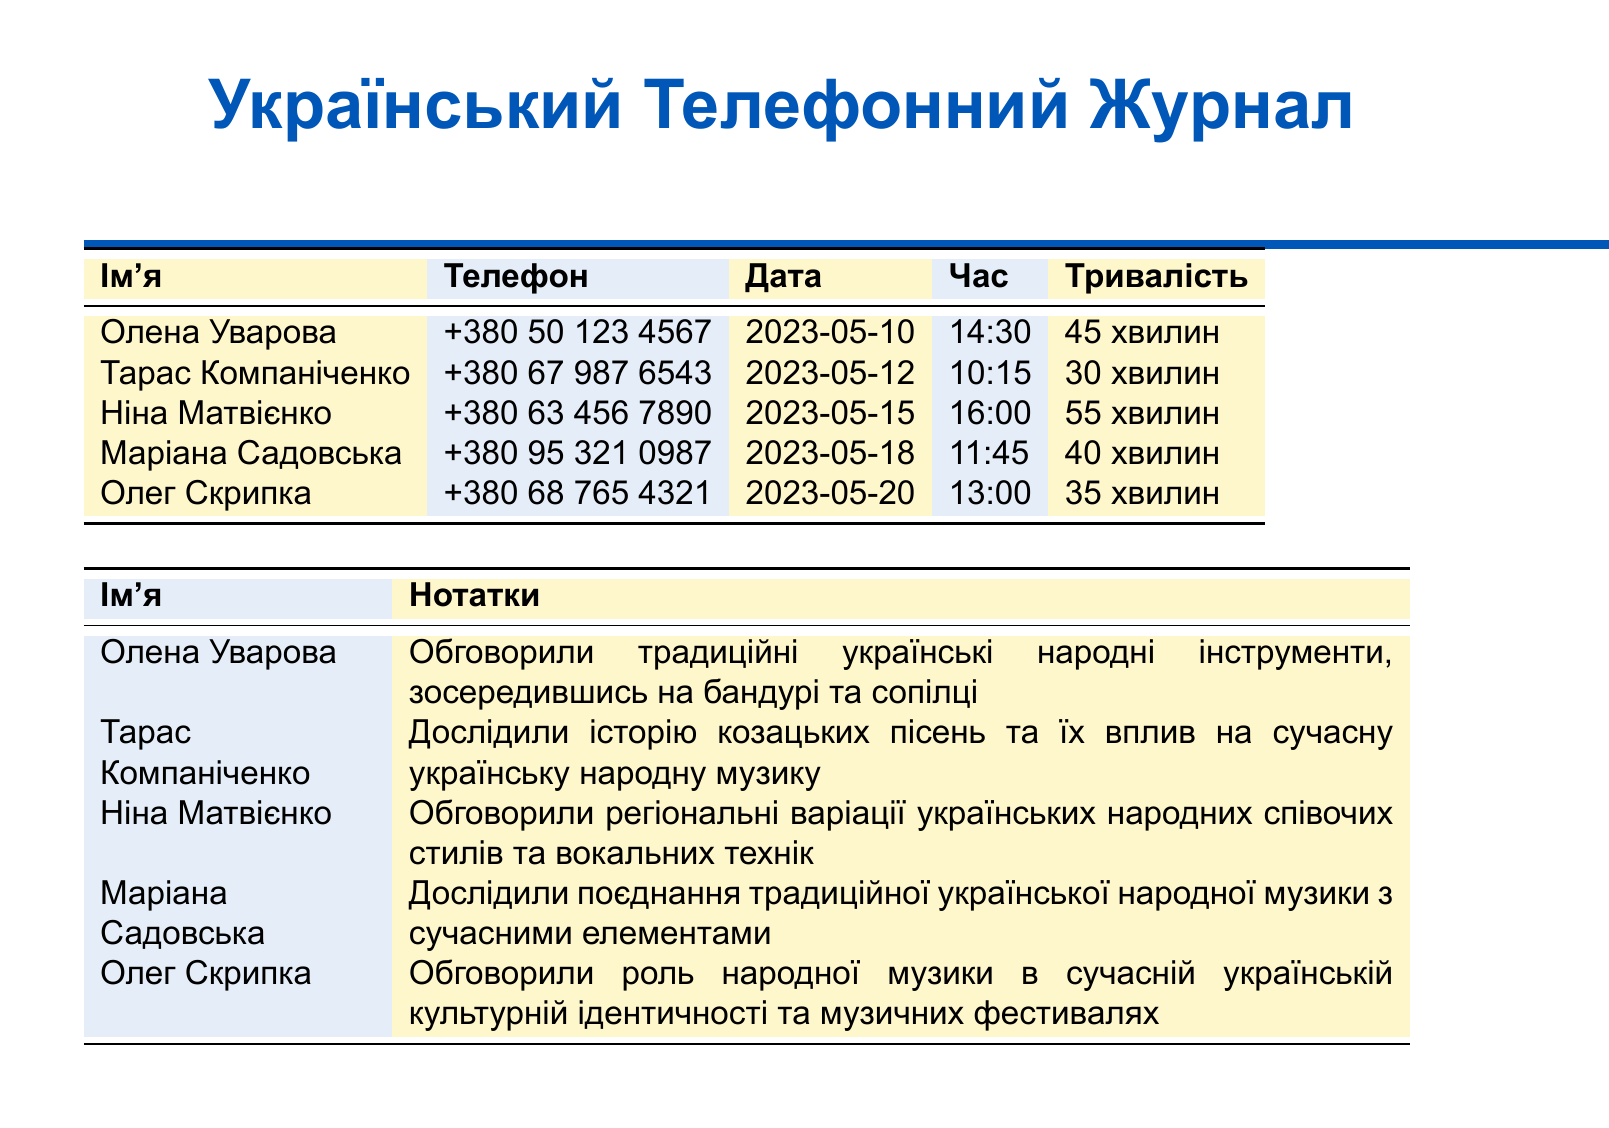What is the total duration of Oлена Уварова's interview? The duration of Oлена Уварова's interview is explicitly stated in the document as 45 minutes.
Answer: 45 хвилин Who interviewed Тарас Компаніченко? The document lists interviews with various musicians, and the name of the interviewer is not explicitly mentioned, thus requiring inference. However, it is implied that the interviewer is the critic compiling the record.
Answer: Ukrainian music critic What is the contact number for Ніна Матвієнко? The contact number is clearly stated next to her name in the document as +380 63 456 7890.
Answer: +380 63 456 7890 On what date was Алеся Сидорова interviewed? The interview date for Алеся Сидорова is not present in the document, requiring reasoning to deduce from given names.
Answer: Not found Which musician had the longest interview? The document provides duration details, and Ніна Матвієнко's interview lasted 55 minutes, making it the longest.
Answer: Ніна Матвієнко What theme was discussed during Олег Скрипка's interview? The notes specify the theme discussed in Олег Скрипка's interview, focusing on the role of folk music in modern cultural identity.
Answer: Народної музики в сучасній українській культурній ідентичності When was Маріана Садовська interviewed? The document lists the date of Маріана Садовська's interview, which is 2023-05-18.
Answer: 2023-05-18 Which instrument was a major focus during Олена Уварова's discussion? The notes indicate that Oлена Уварова focused on traditional instruments like the бандура and сопілка during her conversation.
Answer: бандура, сопілка How many interviews were listed in total? The document lists a total of five interviews with different musicians.
Answer: 5 